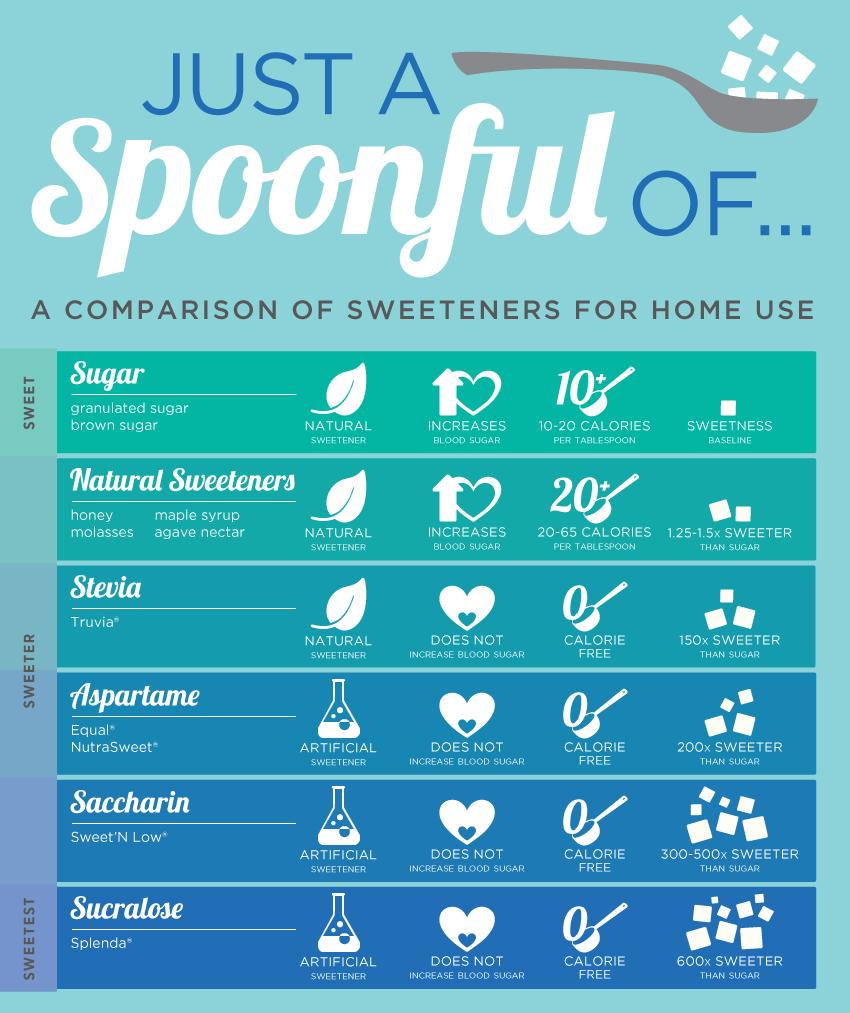Highlight a few significant elements in this photo. Truvia is more sweet than honey but less sweet than Nutrasweet, making it a popular alternative for those looking to reduce their sugar intake without sacrificing taste. There are several artificial sweeteners, including aspartame, saccharin, and sucralose. Stevia is a natural sweetener that does not increase calories or blood pressure. 